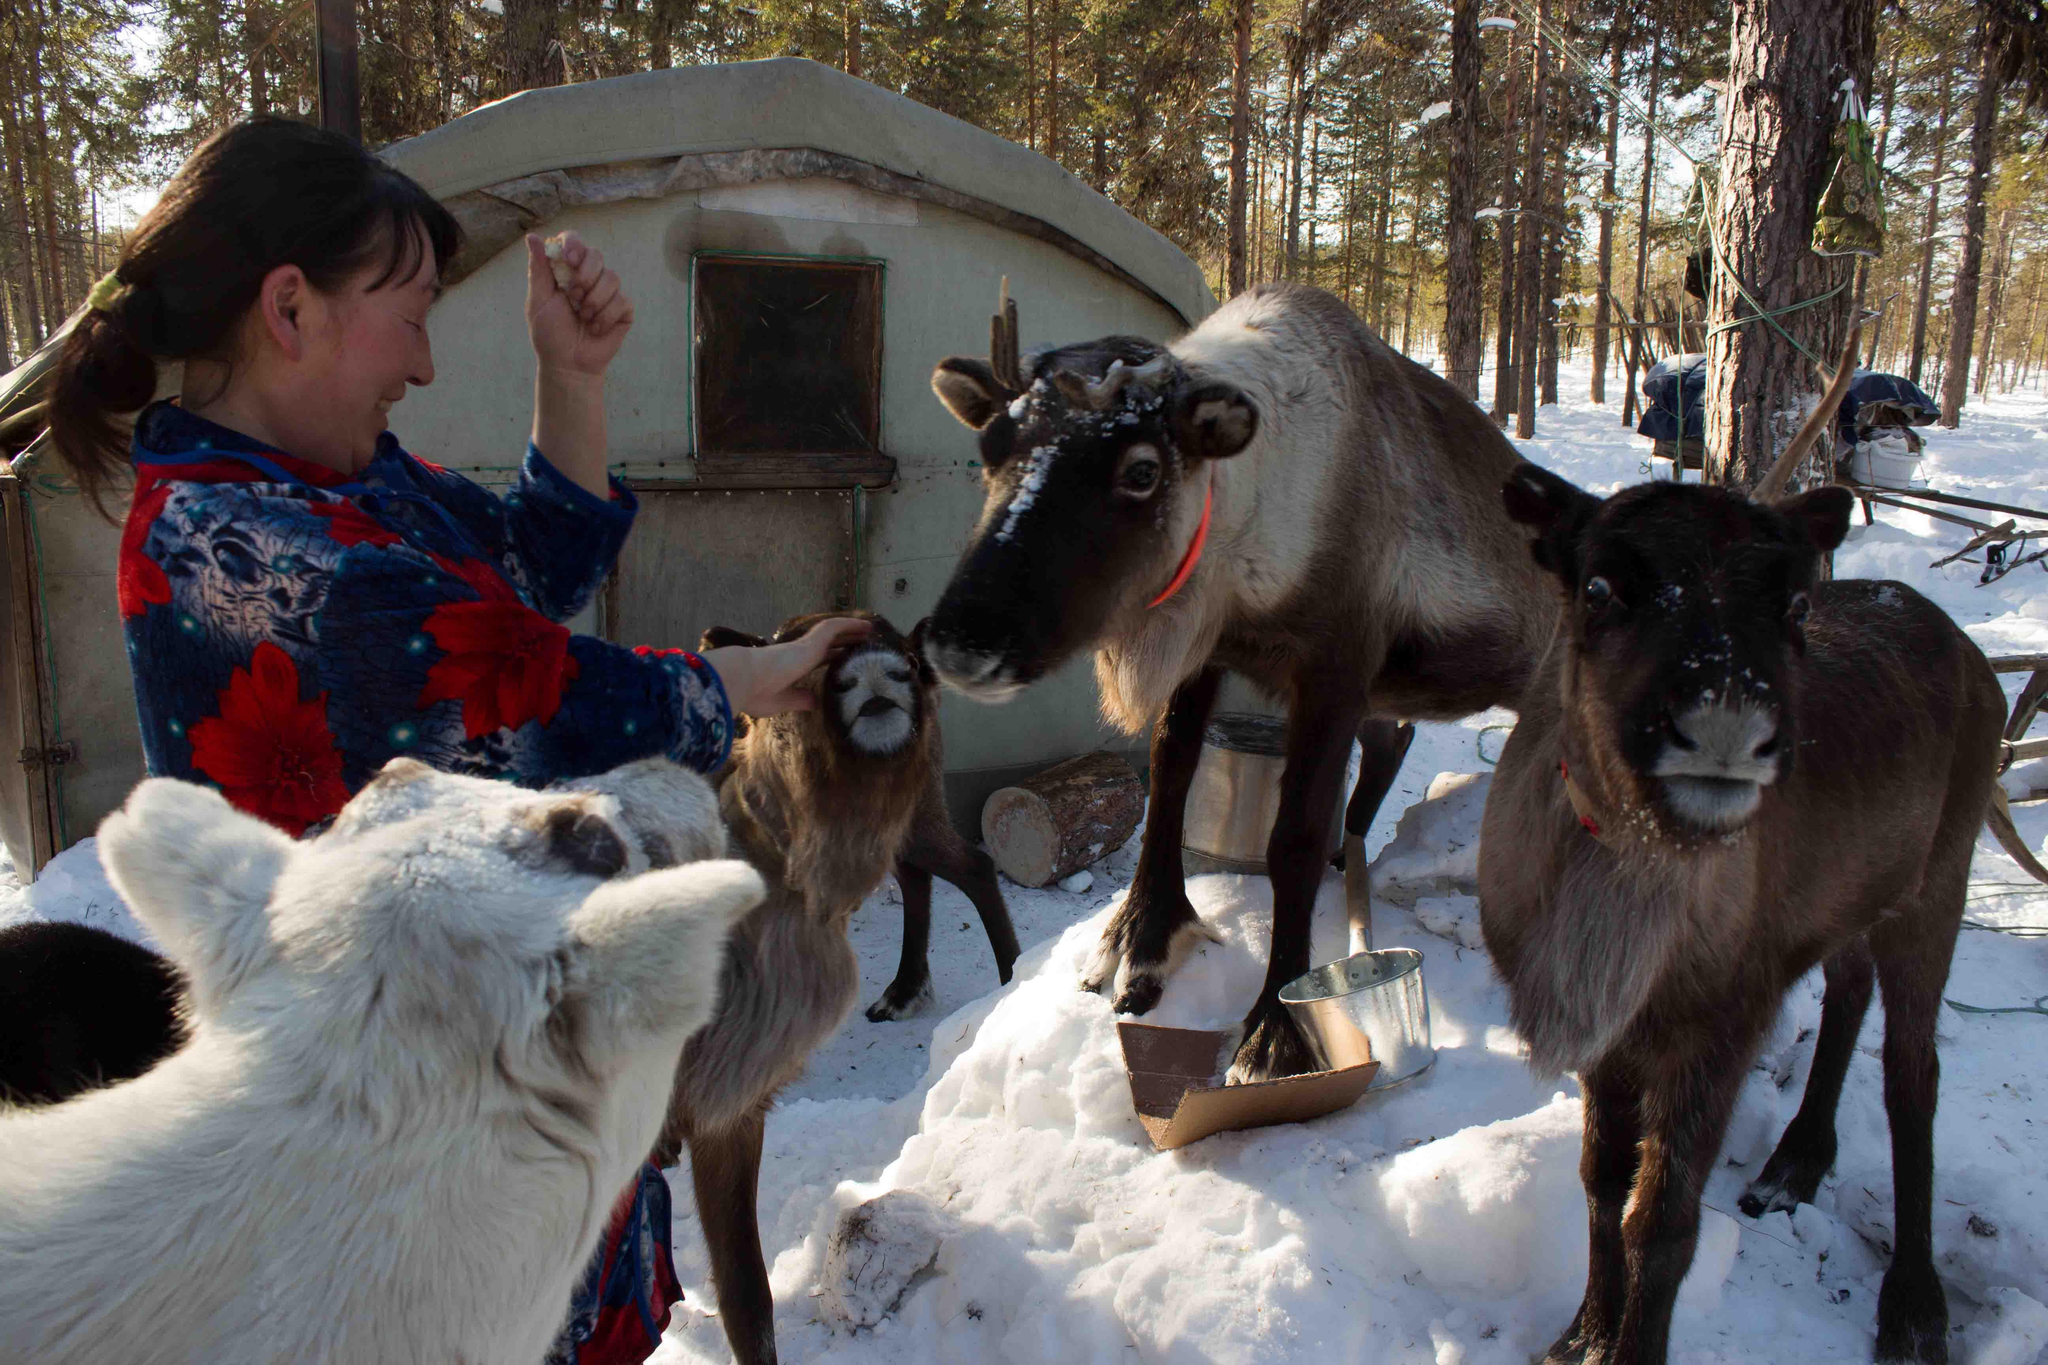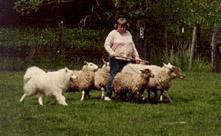The first image is the image on the left, the second image is the image on the right. Given the left and right images, does the statement "A woman holding a stick stands behind multiple woolly sheep and is near a white dog." hold true? Answer yes or no. Yes. 